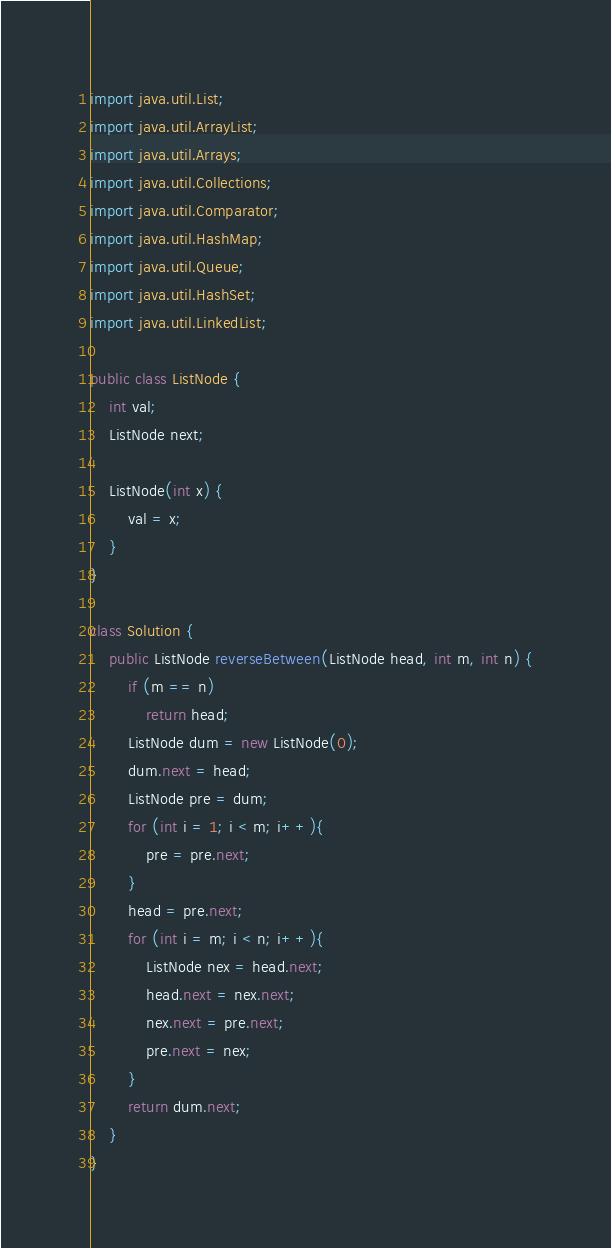Convert code to text. <code><loc_0><loc_0><loc_500><loc_500><_Java_>
import java.util.List;
import java.util.ArrayList;
import java.util.Arrays;
import java.util.Collections;
import java.util.Comparator;
import java.util.HashMap;
import java.util.Queue;
import java.util.HashSet;
import java.util.LinkedList;

public class ListNode {
    int val;
    ListNode next;

    ListNode(int x) {
        val = x;
    }
}

class Solution {
    public ListNode reverseBetween(ListNode head, int m, int n) {
        if (m == n) 
            return head;
        ListNode dum = new ListNode(0);
        dum.next = head;
        ListNode pre = dum;
        for (int i = 1; i < m; i++){
            pre = pre.next;  
        }
        head = pre.next;
        for (int i = m; i < n; i++){
            ListNode nex = head.next;
            head.next = nex.next;
            nex.next = pre.next;
            pre.next = nex;
        }
        return dum.next;
    }
}
</code> 